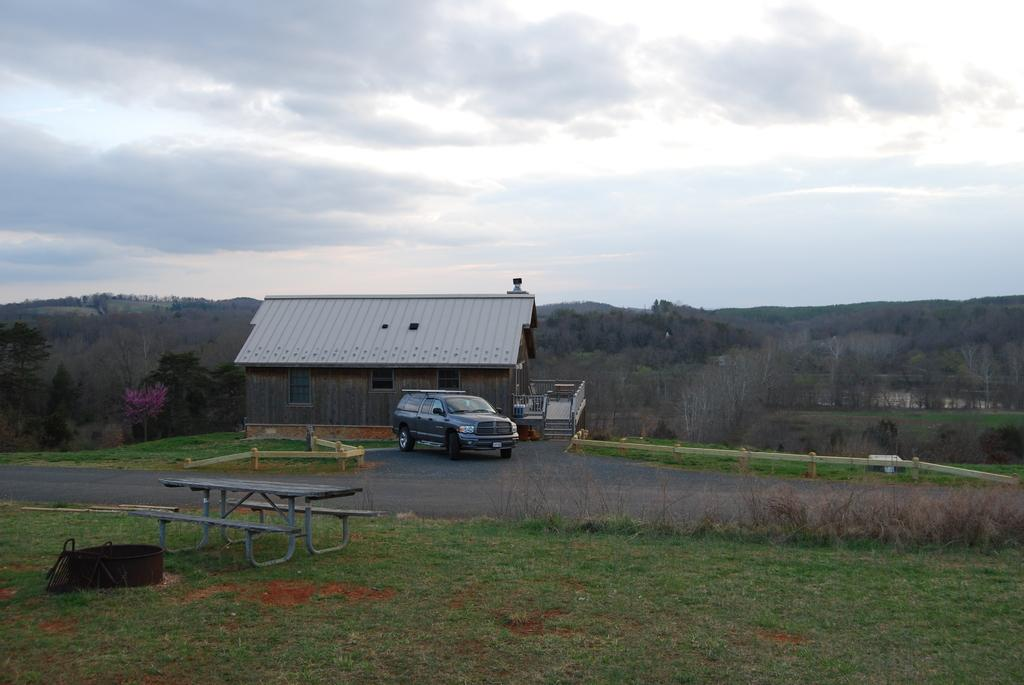What can be seen in the background of the image? There is a sky in the image. What type of vegetation is present in the image? There are trees in the image. What type of structure is visible in the image? There is a house in the image. What mode of transportation can be seen on the road in the image? There is a car on the road in the image. What type of outdoor seating is present in the image? There is a bench in the front of the image. What type of suit can be seen hanging on the chain in the image? There is no suit or chain present in the image. 